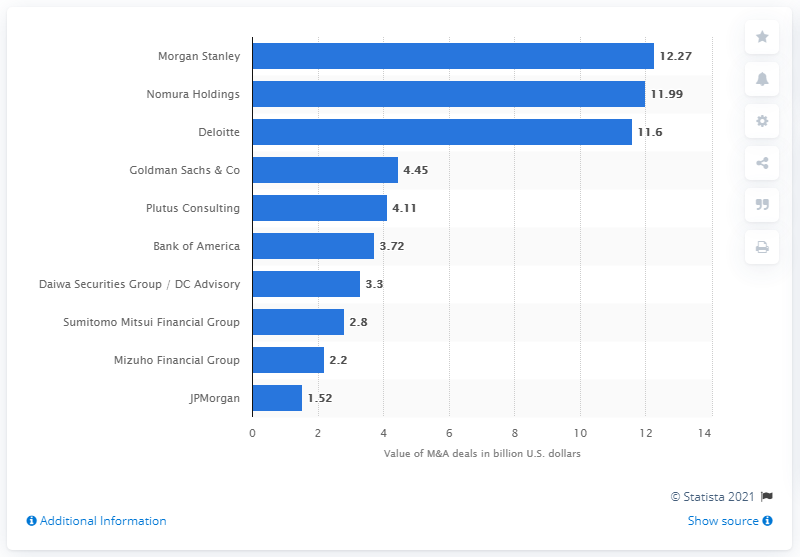List a handful of essential elements in this visual. There are 10 financial advisors present. The deal value in US dollars in Japan during the first half of 2020 was 12.27... Nomura Holdings was the leading financial advisor to mergers and acquisitions in Japan in the first half of 2020, following Morgan Stanley. The sum of values above 10 billion dollars is 35.86. 